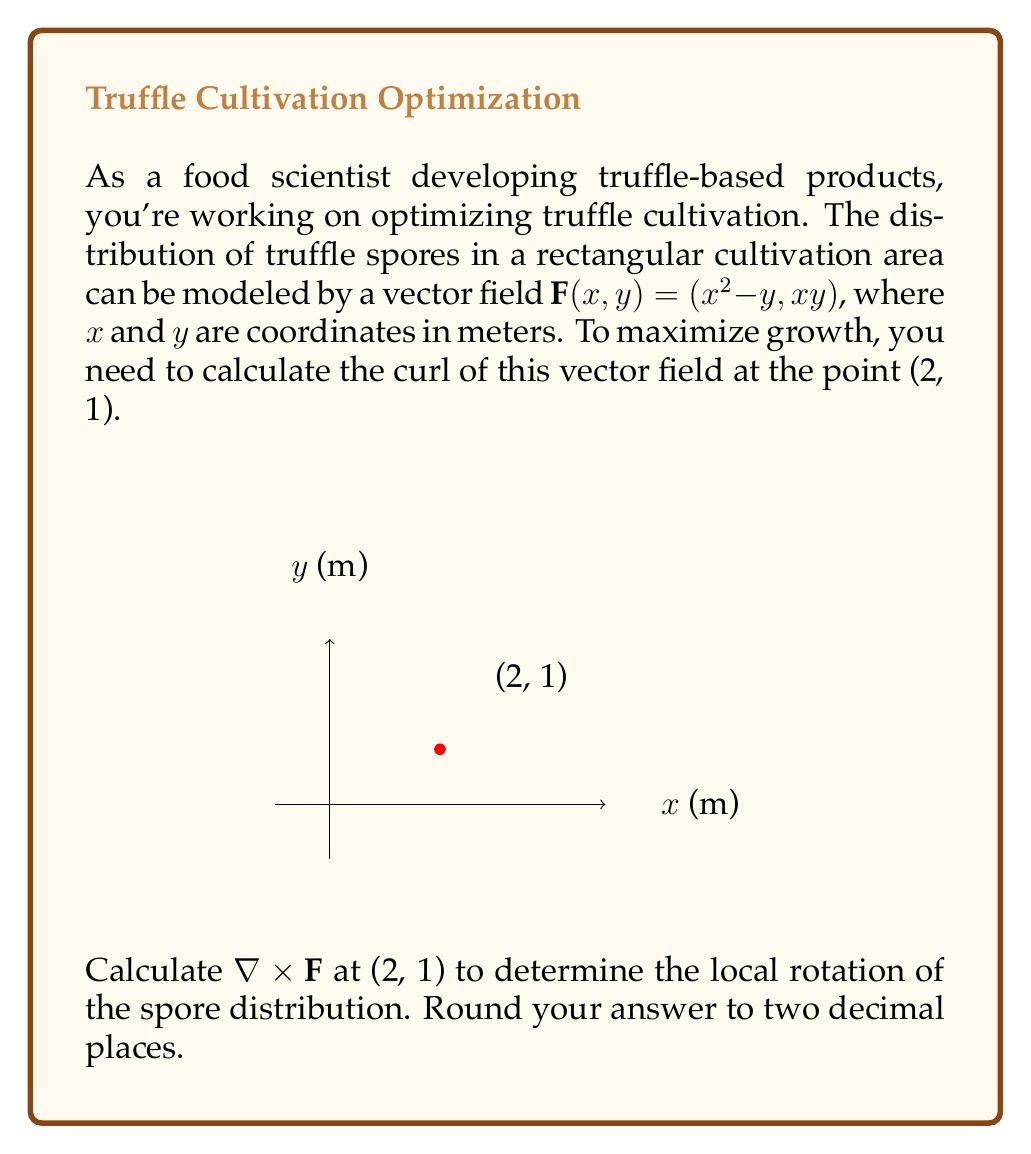Give your solution to this math problem. To solve this problem, we need to follow these steps:

1) The curl of a vector field $\mathbf{F}(x,y) = (P, Q)$ in two dimensions is given by:

   $$\nabla \times \mathbf{F} = \frac{\partial Q}{\partial x} - \frac{\partial P}{\partial y}$$

2) In our case, $P = x^2 - y$ and $Q = xy$. Let's calculate the partial derivatives:

   $$\frac{\partial Q}{\partial x} = \frac{\partial (xy)}{\partial x} = y$$

   $$\frac{\partial P}{\partial y} = \frac{\partial (x^2 - y)}{\partial y} = -1$$

3) Now we can substitute these into the curl formula:

   $$\nabla \times \mathbf{F} = y - (-1) = y + 1$$

4) We need to evaluate this at the point (2, 1). Substituting y = 1:

   $$\nabla \times \mathbf{F}|_{(2,1)} = 1 + 1 = 2$$

5) The question asks for the answer rounded to two decimal places, so our final answer is 2.00.

This positive curl indicates a counterclockwise rotation in the spore distribution at the point (2, 1), which could be useful information for optimizing truffle growth conditions.
Answer: 2.00 